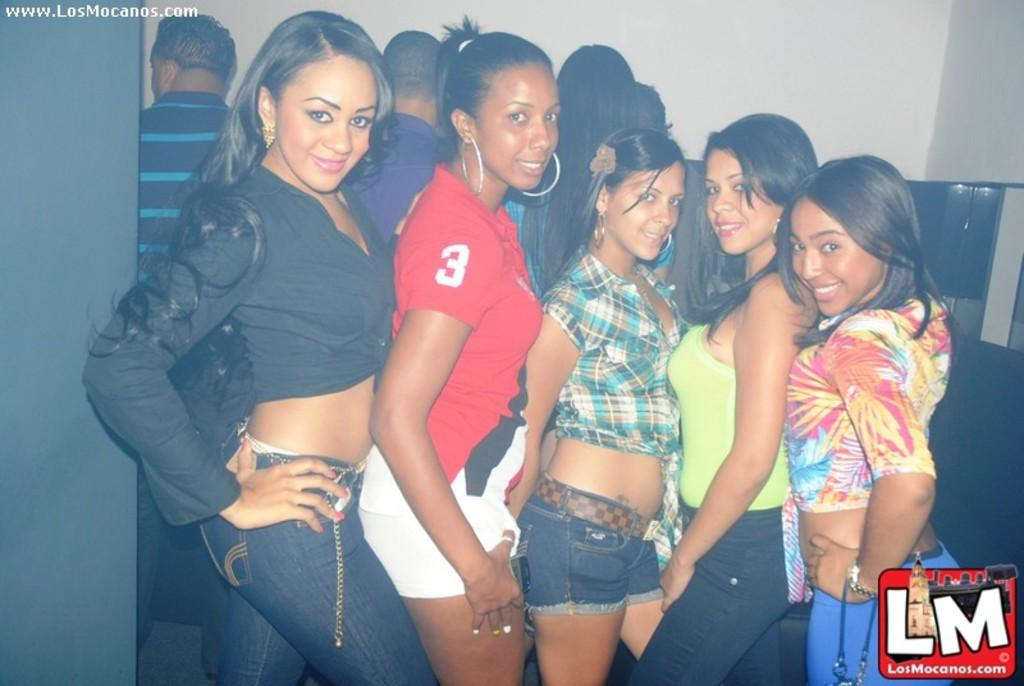What is happening in the image? There are people standing in the image. Can you describe any specific details about the image? There is a logo at the right bottom of the image and a wall in the background. Is there any text visible in the image? Yes, there is some text visible at the left top of the image. What type of sheet is being used by the people in the image? There is no sheet present in the image; it features people standing with a logo, wall, and text. Can you describe the bun that the person in the image is holding? There is no bun present in the image; it only shows people standing with a logo, wall, and text. 